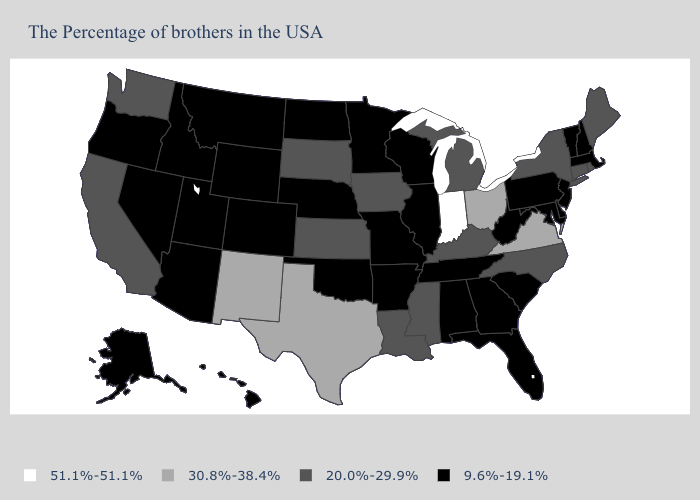What is the value of Alaska?
Short answer required. 9.6%-19.1%. What is the lowest value in the South?
Give a very brief answer. 9.6%-19.1%. Does Maryland have a lower value than North Dakota?
Short answer required. No. Among the states that border Nebraska , does Iowa have the highest value?
Short answer required. Yes. Which states hav the highest value in the MidWest?
Keep it brief. Indiana. What is the value of Ohio?
Quick response, please. 30.8%-38.4%. Which states hav the highest value in the MidWest?
Write a very short answer. Indiana. Does North Carolina have the highest value in the USA?
Answer briefly. No. Among the states that border Massachusetts , which have the lowest value?
Quick response, please. New Hampshire, Vermont. Does the map have missing data?
Short answer required. No. Does the map have missing data?
Give a very brief answer. No. What is the value of Idaho?
Quick response, please. 9.6%-19.1%. What is the lowest value in the USA?
Concise answer only. 9.6%-19.1%. Does Indiana have the lowest value in the USA?
Keep it brief. No. 